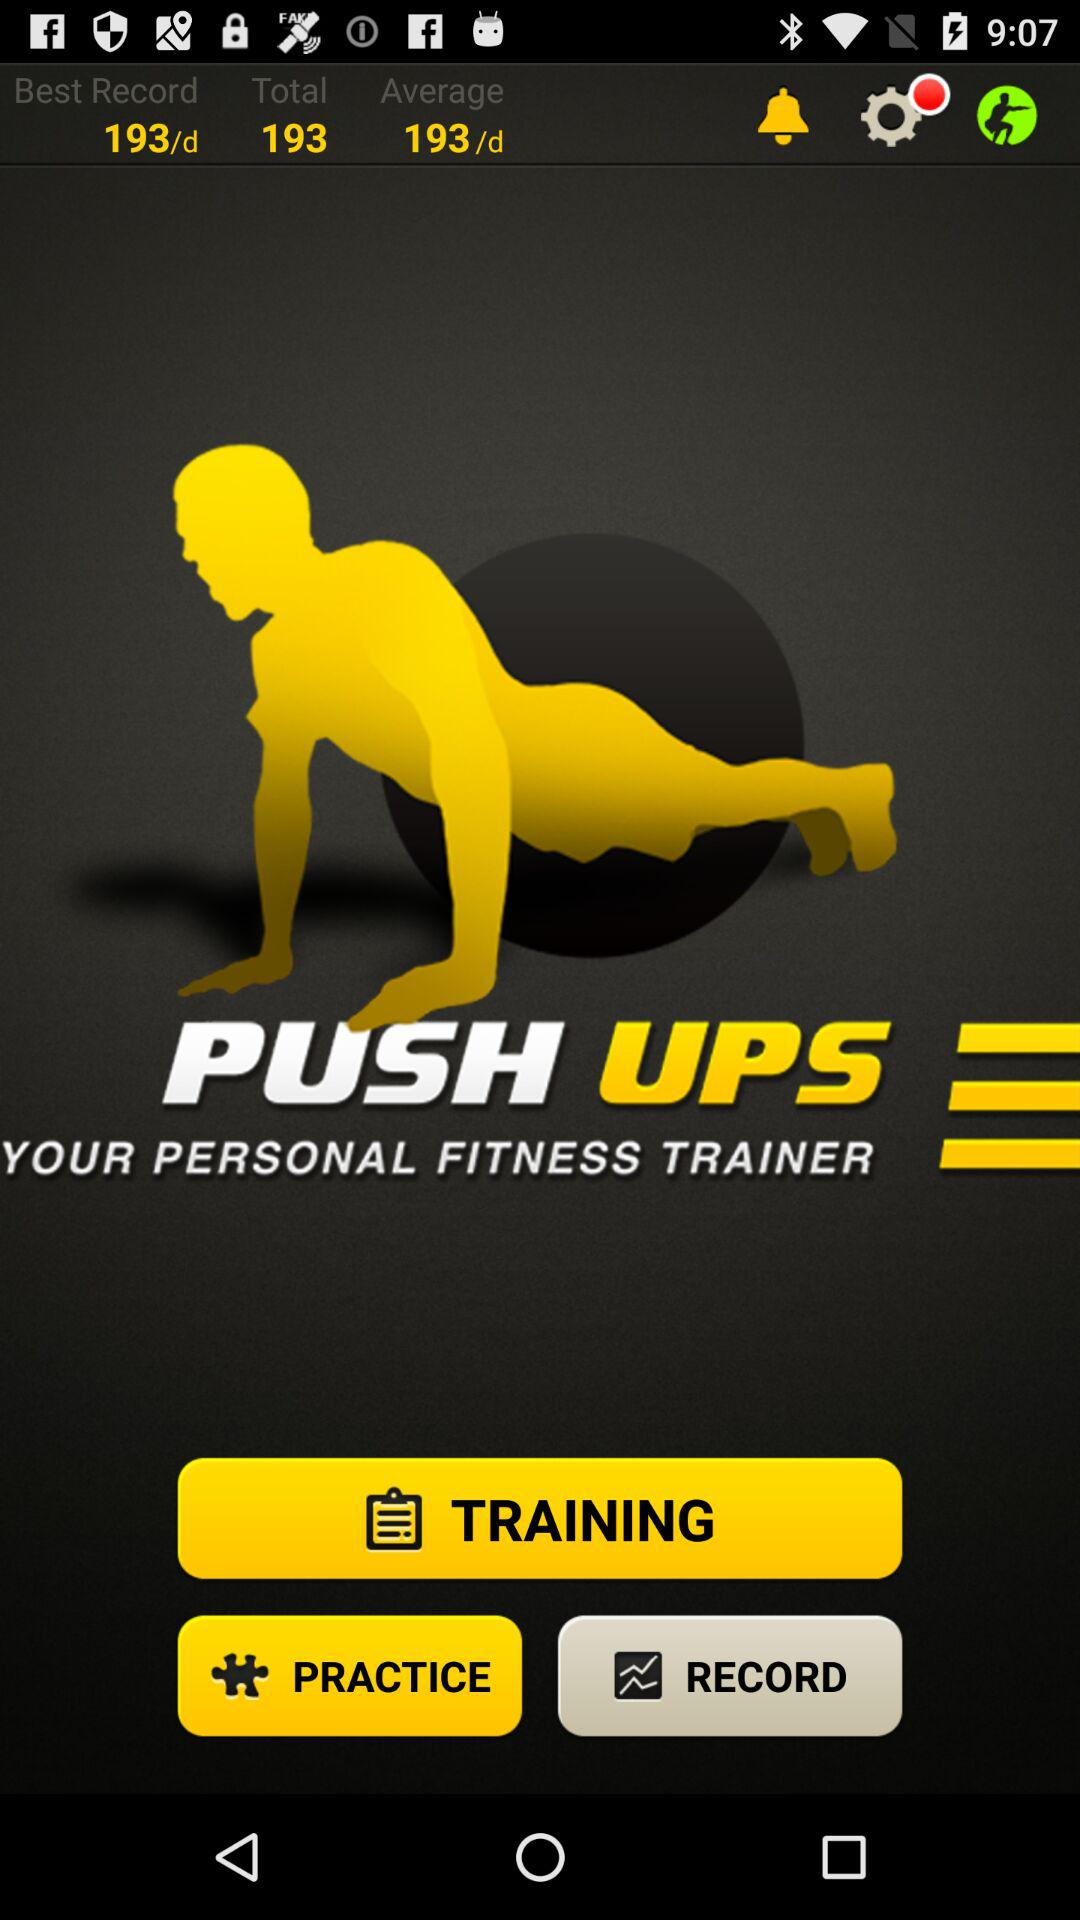What is the total count? The total count is 193. 